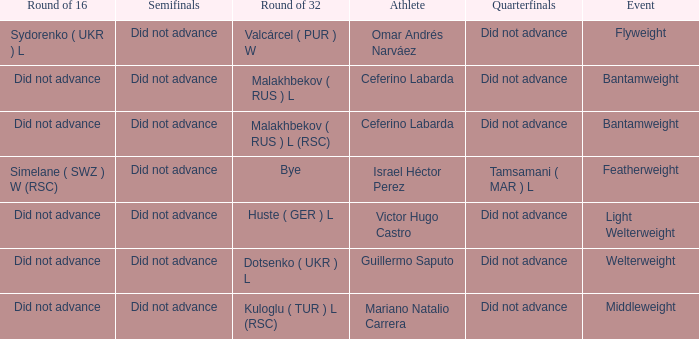When there was a bye in the round of 32, what was the result in the round of 16? Did not advance. 